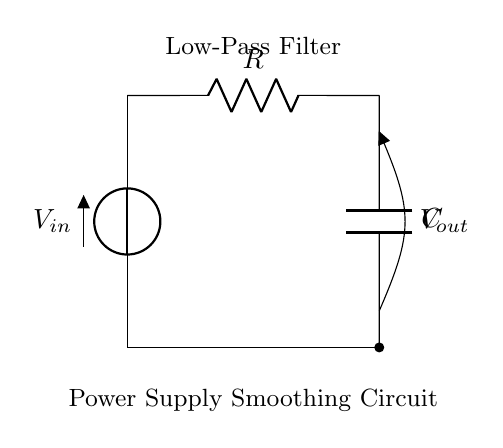What components are in the circuit? The circuit contains a voltage source, a resistor, and a capacitor, which are all standard components in a low-pass filter design.
Answer: voltage source, resistor, capacitor What is the purpose of the resistor in this circuit? The resistor serves to limit the current flowing into the capacitor, helping to define the cutoff frequency of the low-pass filter.
Answer: current limitation What is represented by Vout in the diagram? Vout represents the output voltage across the capacitor, which is the smoothed voltage signal after filtering out high-frequency noise.
Answer: output voltage How does the capacitor affect the output voltage? The capacitor charges to a certain voltage and releases it slowly, which smooths any variations in the input voltage, resulting in a more stable output.
Answer: smoothing effect What is the role of the low-pass filter in electronic devices? The low-pass filter is designed to allow low-frequency signals to pass while attenuating high-frequency noise, ensuring stable power supply operation.
Answer: noise reduction What is the general effect of increasing the capacitance in this circuit? Increasing capacitance lowers the cutoff frequency of the low-pass filter, allowing even lower-frequency signals to be passed while providing greater smoothing of the output voltage.
Answer: lowers cutoff frequency 